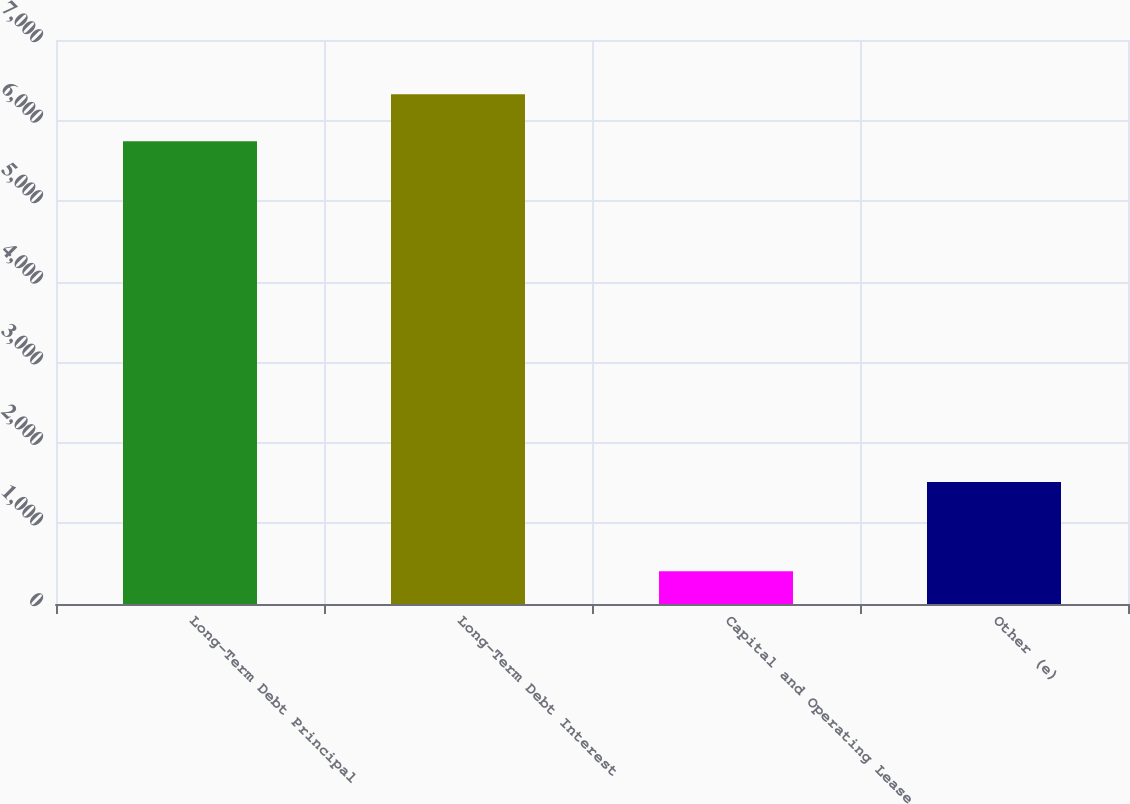Convert chart to OTSL. <chart><loc_0><loc_0><loc_500><loc_500><bar_chart><fcel>Long-Term Debt Principal<fcel>Long-Term Debt Interest<fcel>Capital and Operating Lease<fcel>Other (e)<nl><fcel>5743<fcel>6327.2<fcel>405<fcel>1514<nl></chart> 